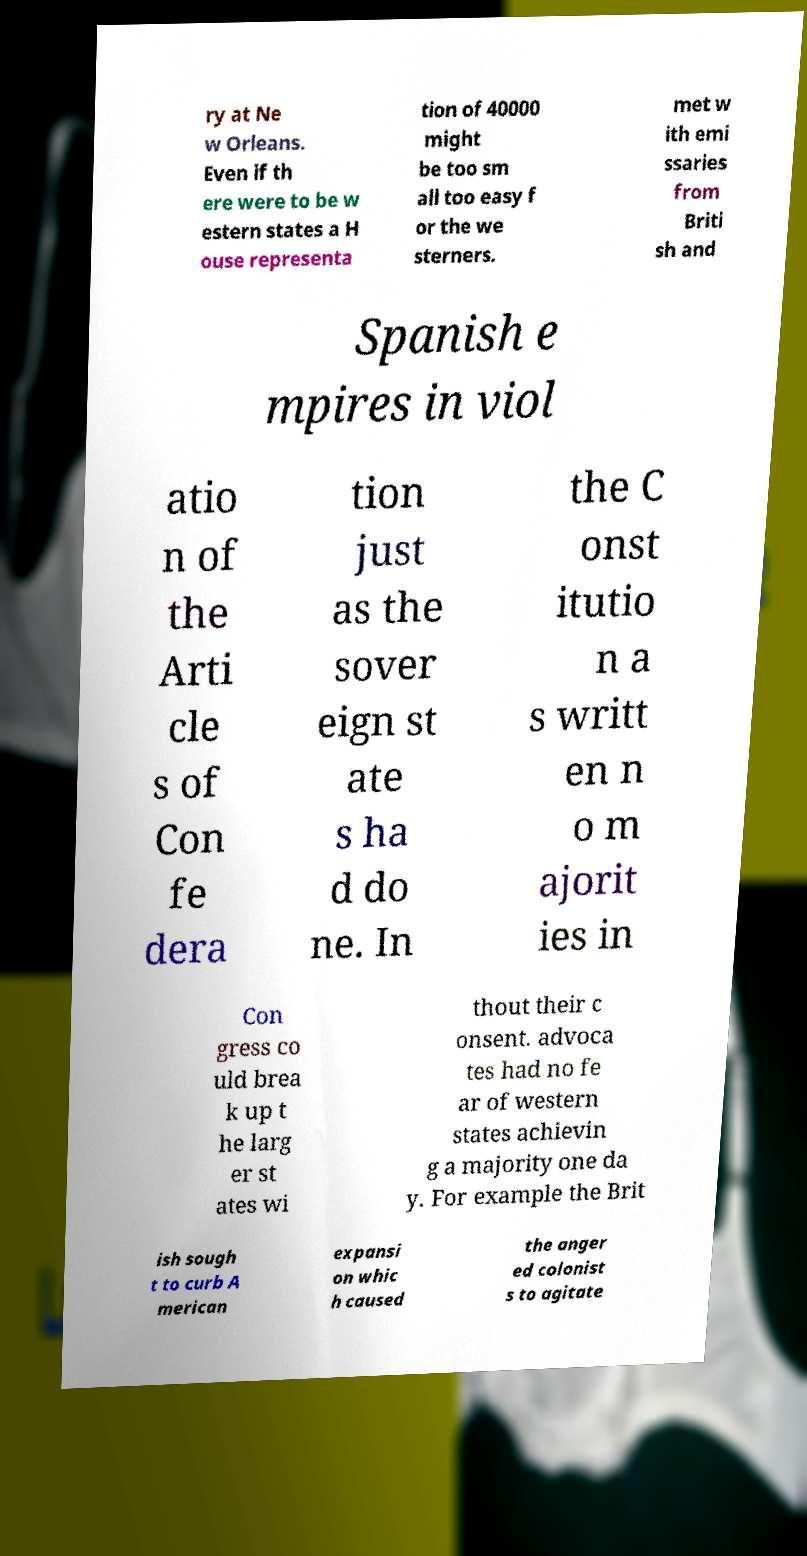Please identify and transcribe the text found in this image. ry at Ne w Orleans. Even if th ere were to be w estern states a H ouse representa tion of 40000 might be too sm all too easy f or the we sterners. met w ith emi ssaries from Briti sh and Spanish e mpires in viol atio n of the Arti cle s of Con fe dera tion just as the sover eign st ate s ha d do ne. In the C onst itutio n a s writt en n o m ajorit ies in Con gress co uld brea k up t he larg er st ates wi thout their c onsent. advoca tes had no fe ar of western states achievin g a majority one da y. For example the Brit ish sough t to curb A merican expansi on whic h caused the anger ed colonist s to agitate 